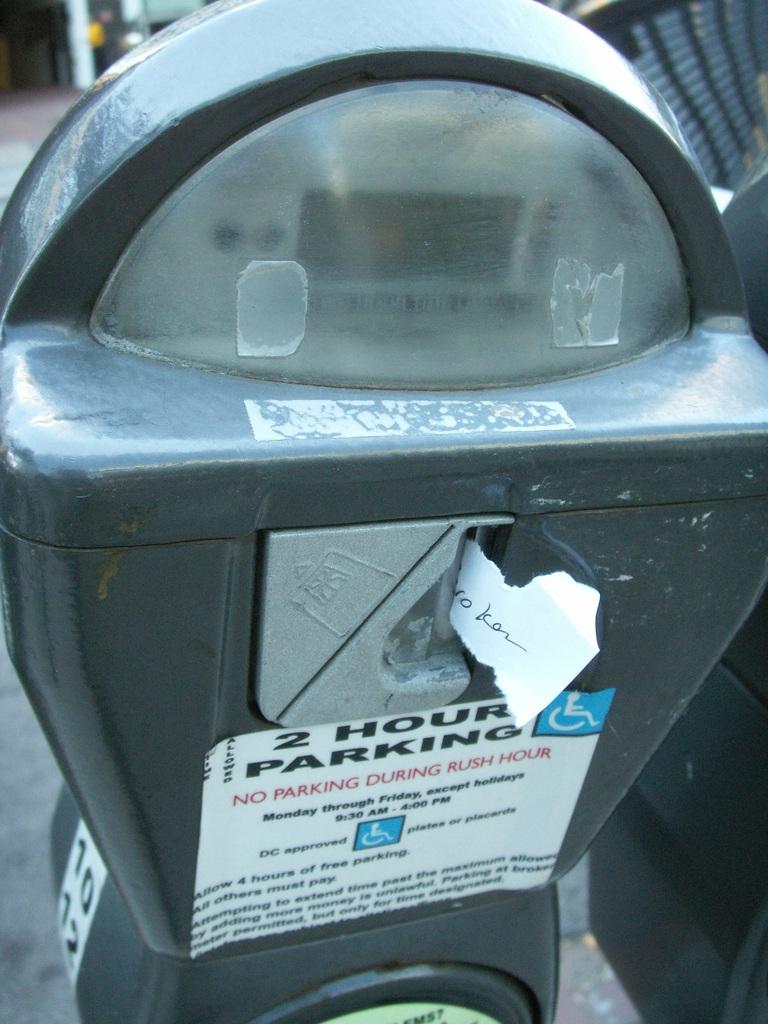How long is the parking?
Provide a short and direct response. 2 hours. Can you park during rush hour?
Provide a succinct answer. No. 